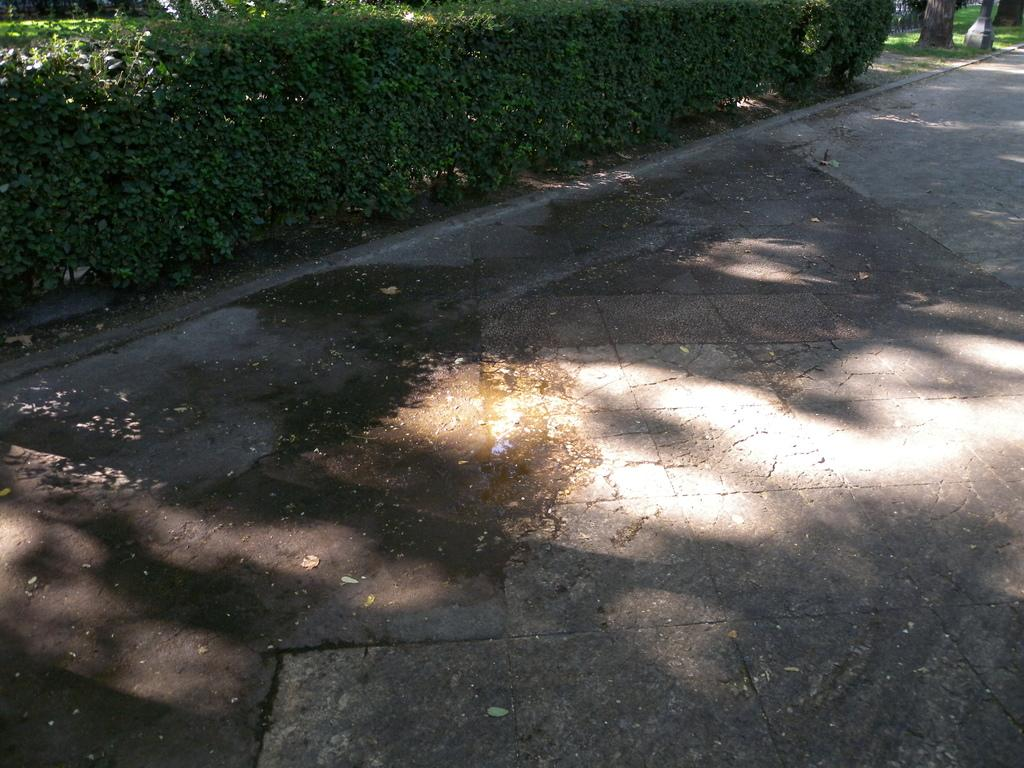What is the main feature of the image? There is a road in the image. What can be seen beside the road? Trees and plants are visible beside the road. What type of instrument is being played by the tree in the image? There is no instrument being played by the tree in the image, as trees do not have the ability to play instruments. 